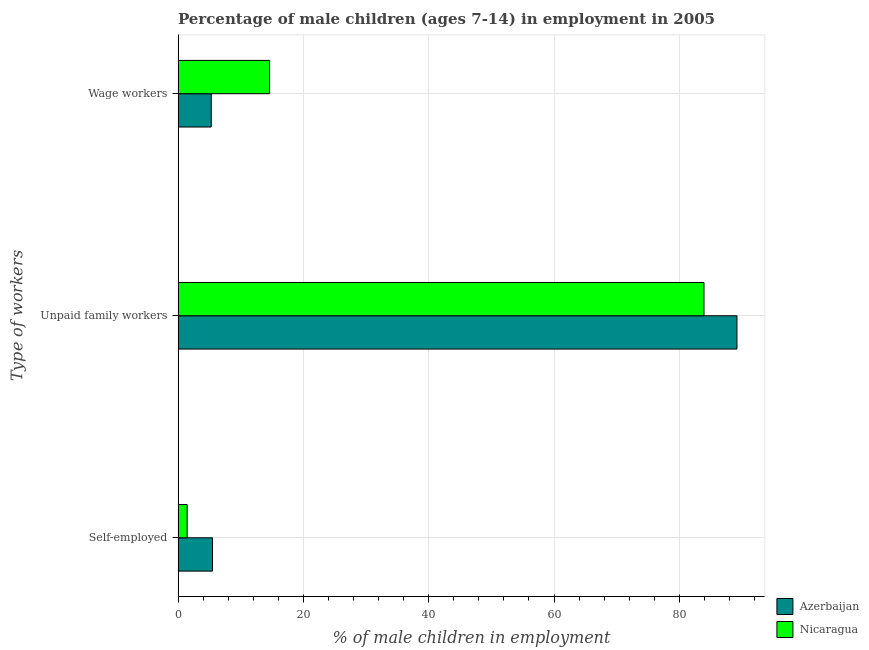Are the number of bars per tick equal to the number of legend labels?
Your response must be concise. Yes. Are the number of bars on each tick of the Y-axis equal?
Keep it short and to the point. Yes. How many bars are there on the 2nd tick from the top?
Offer a terse response. 2. What is the label of the 1st group of bars from the top?
Provide a succinct answer. Wage workers. What is the percentage of self employed children in Nicaragua?
Provide a short and direct response. 1.45. Across all countries, what is the maximum percentage of children employed as unpaid family workers?
Offer a very short reply. 89.2. Across all countries, what is the minimum percentage of self employed children?
Provide a succinct answer. 1.45. In which country was the percentage of self employed children maximum?
Give a very brief answer. Azerbaijan. In which country was the percentage of children employed as wage workers minimum?
Keep it short and to the point. Azerbaijan. What is the total percentage of self employed children in the graph?
Provide a short and direct response. 6.95. What is the difference between the percentage of self employed children in Azerbaijan and that in Nicaragua?
Your response must be concise. 4.05. What is the difference between the percentage of children employed as wage workers in Nicaragua and the percentage of children employed as unpaid family workers in Azerbaijan?
Your response must be concise. -74.59. What is the average percentage of children employed as wage workers per country?
Your answer should be compact. 9.96. What is the difference between the percentage of self employed children and percentage of children employed as unpaid family workers in Nicaragua?
Make the answer very short. -82.49. What is the ratio of the percentage of children employed as wage workers in Nicaragua to that in Azerbaijan?
Make the answer very short. 2.76. Is the percentage of children employed as wage workers in Azerbaijan less than that in Nicaragua?
Your answer should be very brief. Yes. What is the difference between the highest and the second highest percentage of children employed as wage workers?
Make the answer very short. 9.31. What is the difference between the highest and the lowest percentage of children employed as wage workers?
Make the answer very short. 9.31. In how many countries, is the percentage of self employed children greater than the average percentage of self employed children taken over all countries?
Provide a succinct answer. 1. What does the 1st bar from the top in Self-employed represents?
Your answer should be very brief. Nicaragua. What does the 2nd bar from the bottom in Unpaid family workers represents?
Provide a short and direct response. Nicaragua. Is it the case that in every country, the sum of the percentage of self employed children and percentage of children employed as unpaid family workers is greater than the percentage of children employed as wage workers?
Give a very brief answer. Yes. How many bars are there?
Offer a terse response. 6. Are all the bars in the graph horizontal?
Offer a very short reply. Yes. How many countries are there in the graph?
Provide a short and direct response. 2. Does the graph contain any zero values?
Your response must be concise. No. Does the graph contain grids?
Offer a terse response. Yes. How are the legend labels stacked?
Offer a terse response. Vertical. What is the title of the graph?
Give a very brief answer. Percentage of male children (ages 7-14) in employment in 2005. What is the label or title of the X-axis?
Ensure brevity in your answer.  % of male children in employment. What is the label or title of the Y-axis?
Your answer should be compact. Type of workers. What is the % of male children in employment of Nicaragua in Self-employed?
Provide a succinct answer. 1.45. What is the % of male children in employment in Azerbaijan in Unpaid family workers?
Give a very brief answer. 89.2. What is the % of male children in employment of Nicaragua in Unpaid family workers?
Keep it short and to the point. 83.94. What is the % of male children in employment in Nicaragua in Wage workers?
Offer a terse response. 14.61. Across all Type of workers, what is the maximum % of male children in employment of Azerbaijan?
Provide a succinct answer. 89.2. Across all Type of workers, what is the maximum % of male children in employment of Nicaragua?
Keep it short and to the point. 83.94. Across all Type of workers, what is the minimum % of male children in employment of Azerbaijan?
Offer a terse response. 5.3. Across all Type of workers, what is the minimum % of male children in employment of Nicaragua?
Your answer should be compact. 1.45. What is the total % of male children in employment in Nicaragua in the graph?
Ensure brevity in your answer.  100. What is the difference between the % of male children in employment in Azerbaijan in Self-employed and that in Unpaid family workers?
Ensure brevity in your answer.  -83.7. What is the difference between the % of male children in employment of Nicaragua in Self-employed and that in Unpaid family workers?
Make the answer very short. -82.49. What is the difference between the % of male children in employment of Azerbaijan in Self-employed and that in Wage workers?
Keep it short and to the point. 0.2. What is the difference between the % of male children in employment in Nicaragua in Self-employed and that in Wage workers?
Offer a very short reply. -13.16. What is the difference between the % of male children in employment of Azerbaijan in Unpaid family workers and that in Wage workers?
Your response must be concise. 83.9. What is the difference between the % of male children in employment of Nicaragua in Unpaid family workers and that in Wage workers?
Offer a very short reply. 69.33. What is the difference between the % of male children in employment of Azerbaijan in Self-employed and the % of male children in employment of Nicaragua in Unpaid family workers?
Your response must be concise. -78.44. What is the difference between the % of male children in employment of Azerbaijan in Self-employed and the % of male children in employment of Nicaragua in Wage workers?
Provide a succinct answer. -9.11. What is the difference between the % of male children in employment in Azerbaijan in Unpaid family workers and the % of male children in employment in Nicaragua in Wage workers?
Provide a short and direct response. 74.59. What is the average % of male children in employment of Azerbaijan per Type of workers?
Your answer should be compact. 33.33. What is the average % of male children in employment in Nicaragua per Type of workers?
Provide a succinct answer. 33.33. What is the difference between the % of male children in employment of Azerbaijan and % of male children in employment of Nicaragua in Self-employed?
Offer a very short reply. 4.05. What is the difference between the % of male children in employment of Azerbaijan and % of male children in employment of Nicaragua in Unpaid family workers?
Make the answer very short. 5.26. What is the difference between the % of male children in employment of Azerbaijan and % of male children in employment of Nicaragua in Wage workers?
Your answer should be compact. -9.31. What is the ratio of the % of male children in employment in Azerbaijan in Self-employed to that in Unpaid family workers?
Your response must be concise. 0.06. What is the ratio of the % of male children in employment of Nicaragua in Self-employed to that in Unpaid family workers?
Offer a very short reply. 0.02. What is the ratio of the % of male children in employment in Azerbaijan in Self-employed to that in Wage workers?
Make the answer very short. 1.04. What is the ratio of the % of male children in employment of Nicaragua in Self-employed to that in Wage workers?
Offer a very short reply. 0.1. What is the ratio of the % of male children in employment in Azerbaijan in Unpaid family workers to that in Wage workers?
Offer a terse response. 16.83. What is the ratio of the % of male children in employment in Nicaragua in Unpaid family workers to that in Wage workers?
Make the answer very short. 5.75. What is the difference between the highest and the second highest % of male children in employment in Azerbaijan?
Make the answer very short. 83.7. What is the difference between the highest and the second highest % of male children in employment in Nicaragua?
Make the answer very short. 69.33. What is the difference between the highest and the lowest % of male children in employment of Azerbaijan?
Offer a very short reply. 83.9. What is the difference between the highest and the lowest % of male children in employment of Nicaragua?
Your answer should be compact. 82.49. 